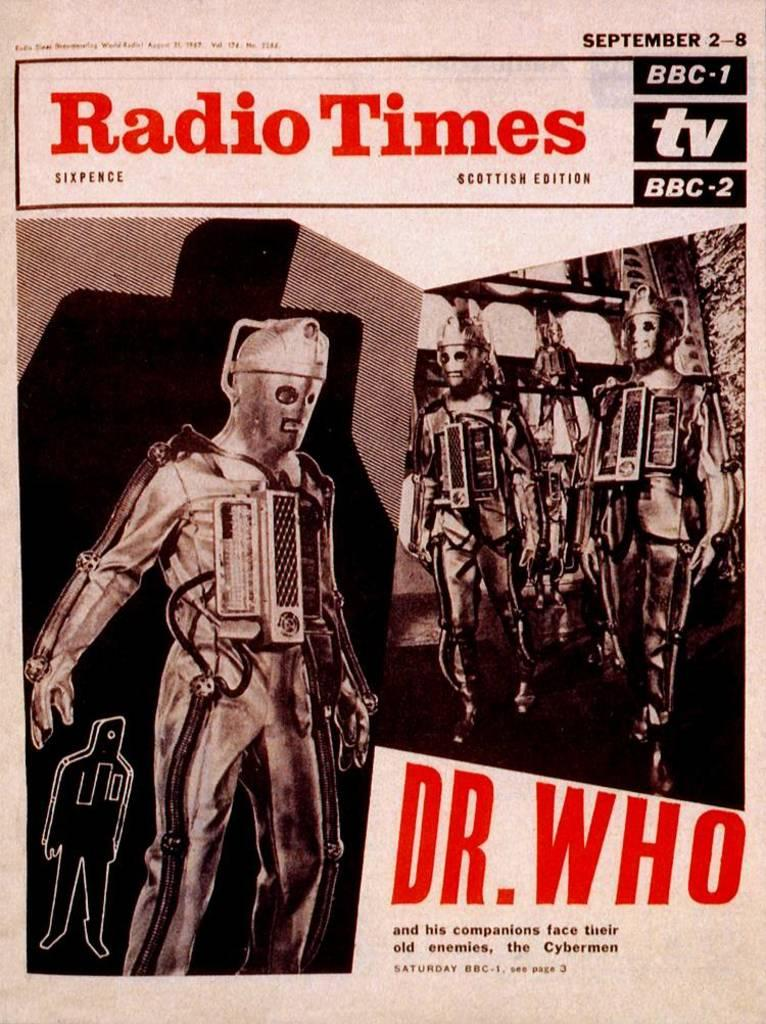<image>
Write a terse but informative summary of the picture. Dr Who and his companions are on the cover of Radio Times. 